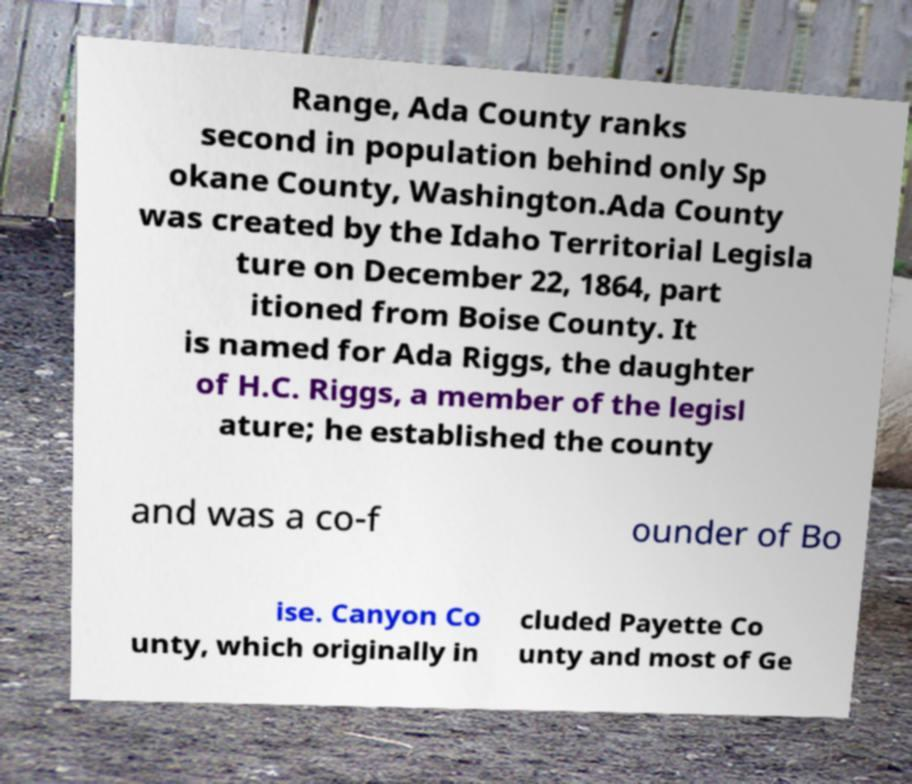For documentation purposes, I need the text within this image transcribed. Could you provide that? Range, Ada County ranks second in population behind only Sp okane County, Washington.Ada County was created by the Idaho Territorial Legisla ture on December 22, 1864, part itioned from Boise County. It is named for Ada Riggs, the daughter of H.C. Riggs, a member of the legisl ature; he established the county and was a co-f ounder of Bo ise. Canyon Co unty, which originally in cluded Payette Co unty and most of Ge 